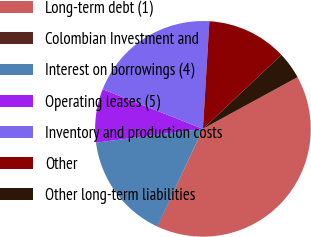Convert chart to OTSL. <chart><loc_0><loc_0><loc_500><loc_500><pie_chart><fcel>Long-term debt (1)<fcel>Colombian Investment and<fcel>Interest on borrowings (4)<fcel>Operating leases (5)<fcel>Inventory and production costs<fcel>Other<fcel>Other long-term liabilities<nl><fcel>39.83%<fcel>0.09%<fcel>15.99%<fcel>8.04%<fcel>19.96%<fcel>12.02%<fcel>4.07%<nl></chart> 